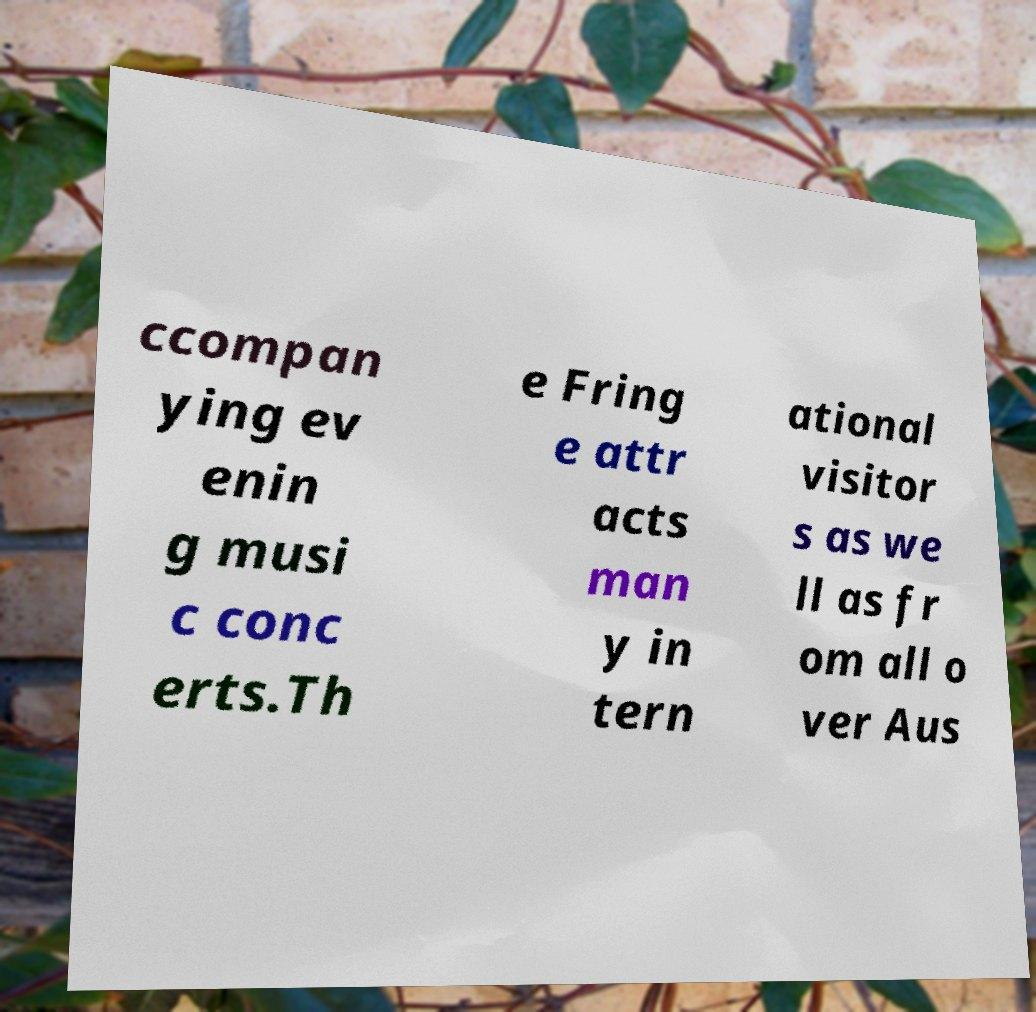Can you read and provide the text displayed in the image?This photo seems to have some interesting text. Can you extract and type it out for me? ccompan ying ev enin g musi c conc erts.Th e Fring e attr acts man y in tern ational visitor s as we ll as fr om all o ver Aus 